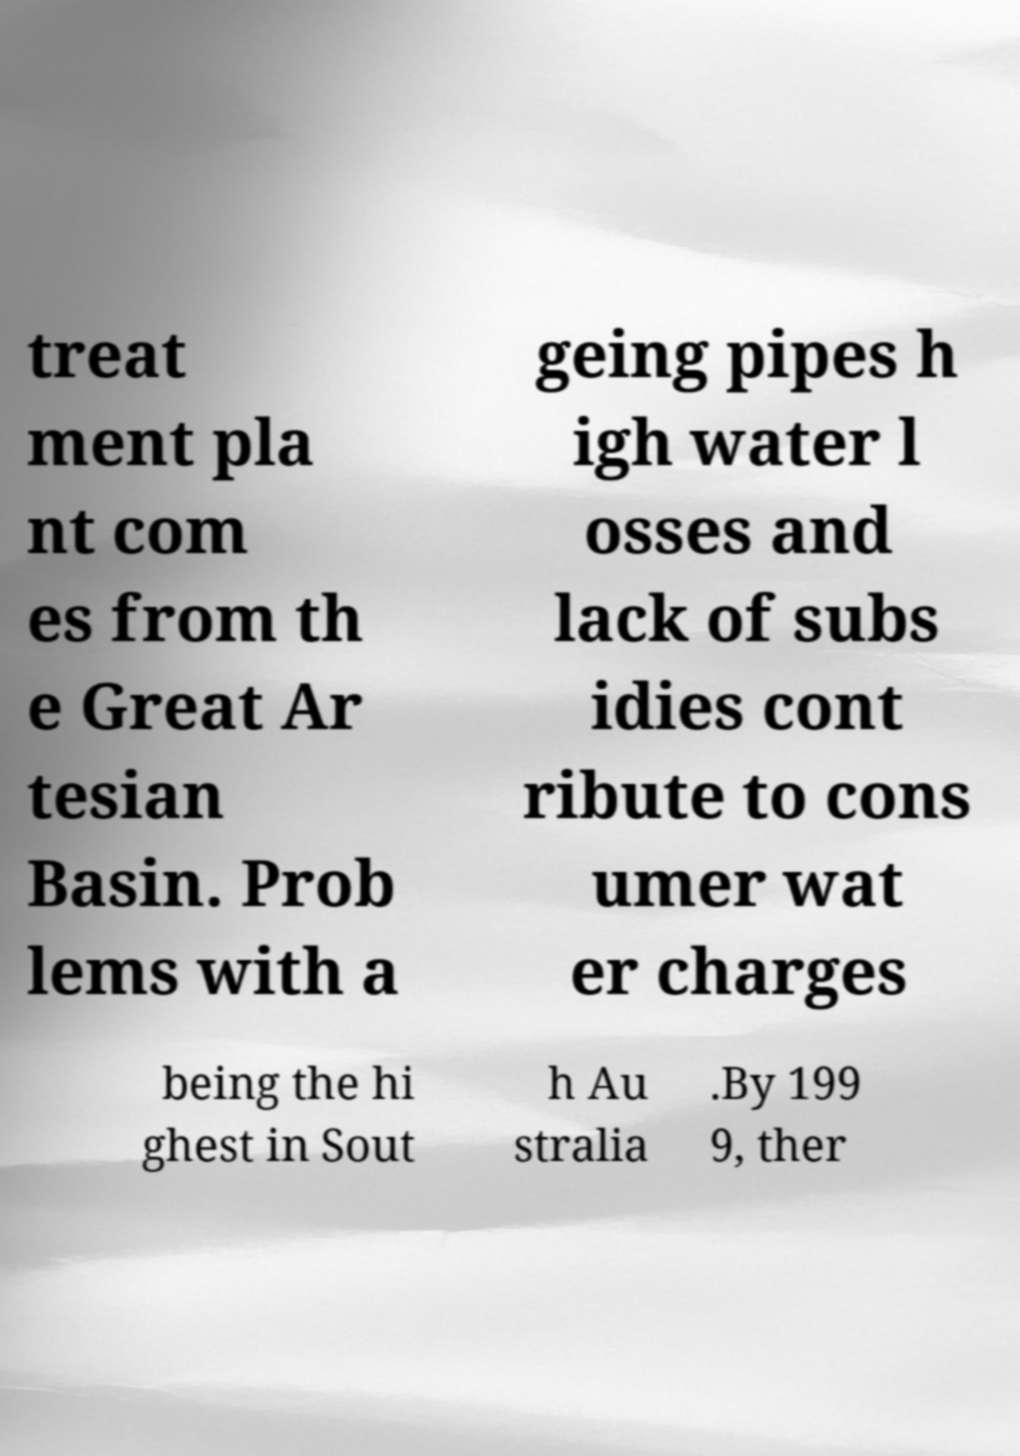What messages or text are displayed in this image? I need them in a readable, typed format. treat ment pla nt com es from th e Great Ar tesian Basin. Prob lems with a geing pipes h igh water l osses and lack of subs idies cont ribute to cons umer wat er charges being the hi ghest in Sout h Au stralia .By 199 9, ther 